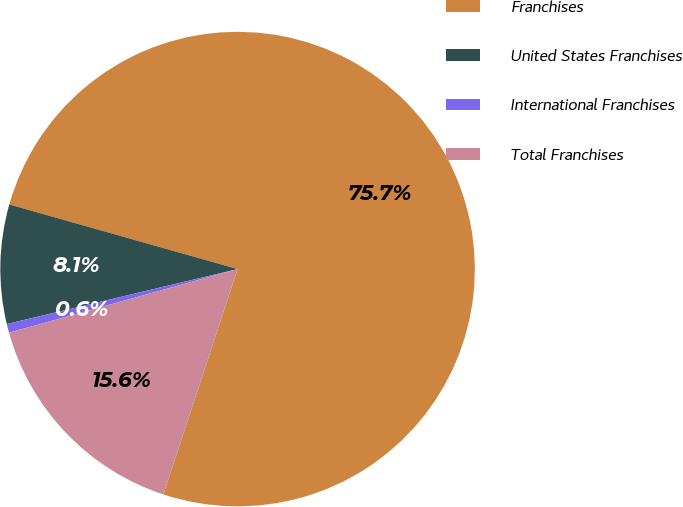<chart> <loc_0><loc_0><loc_500><loc_500><pie_chart><fcel>Franchises<fcel>United States Franchises<fcel>International Franchises<fcel>Total Franchises<nl><fcel>75.67%<fcel>8.11%<fcel>0.6%<fcel>15.62%<nl></chart> 